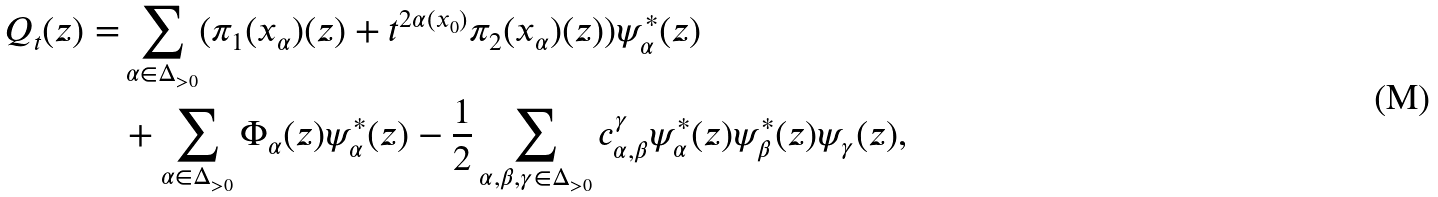Convert formula to latex. <formula><loc_0><loc_0><loc_500><loc_500>Q _ { t } ( z ) = & \sum _ { \alpha \in \Delta _ { > 0 } } ( \pi _ { 1 } ( x _ { \alpha } ) ( z ) + t ^ { 2 \alpha ( x _ { 0 } ) } \pi _ { 2 } ( x _ { \alpha } ) ( z ) ) \psi _ { \alpha } ^ { * } ( z ) \\ & + \sum _ { \alpha \in \Delta _ { > 0 } } \Phi _ { \alpha } ( z ) \psi _ { \alpha } ^ { * } ( z ) - \frac { 1 } { 2 } \sum _ { \alpha , \beta , \gamma \in \Delta _ { > 0 } } c _ { \alpha , \beta } ^ { \gamma } \psi _ { \alpha } ^ { * } ( z ) \psi _ { \beta } ^ { * } ( z ) \psi _ { \gamma } ( z ) ,</formula> 